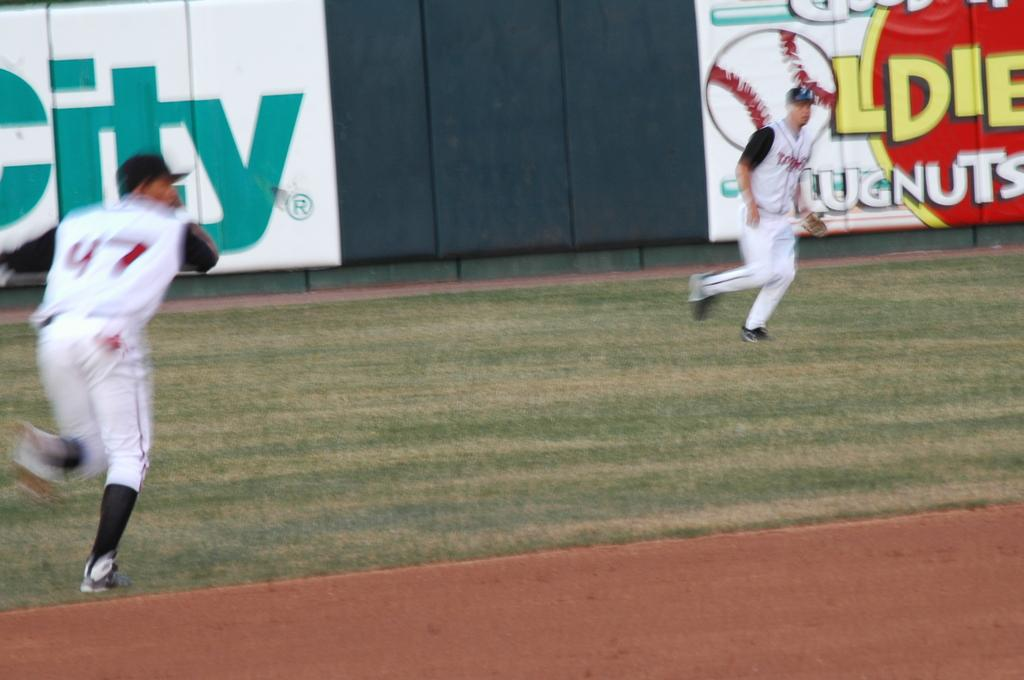Provide a one-sentence caption for the provided image. A baseball game with a O as a baseball on the wall. 